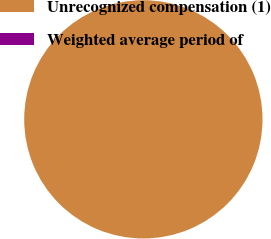<chart> <loc_0><loc_0><loc_500><loc_500><pie_chart><fcel>Unrecognized compensation (1)<fcel>Weighted average period of<nl><fcel>100.0%<fcel>0.0%<nl></chart> 